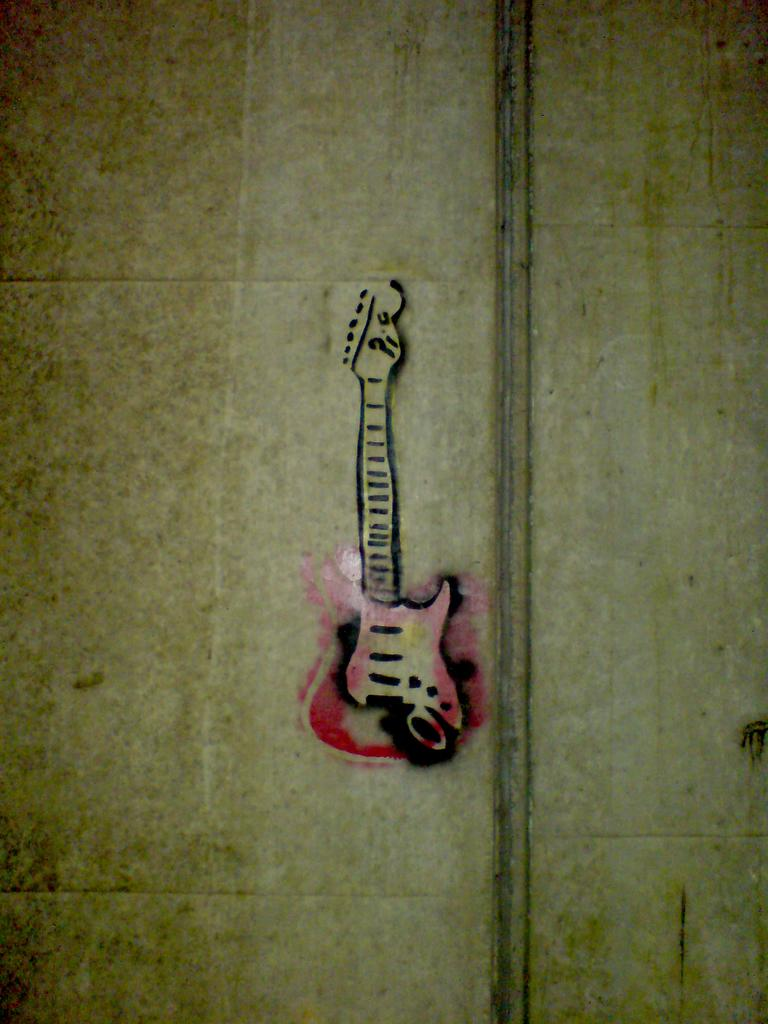What is the main subject in the center of the image? There is a wall in the center of the image. What is depicted on the wall? There is a painting of a guitar on the wall. What type of jelly can be seen dripping from the guitar in the painting? There is no jelly present in the image, and the painting does not depict any jelly. 